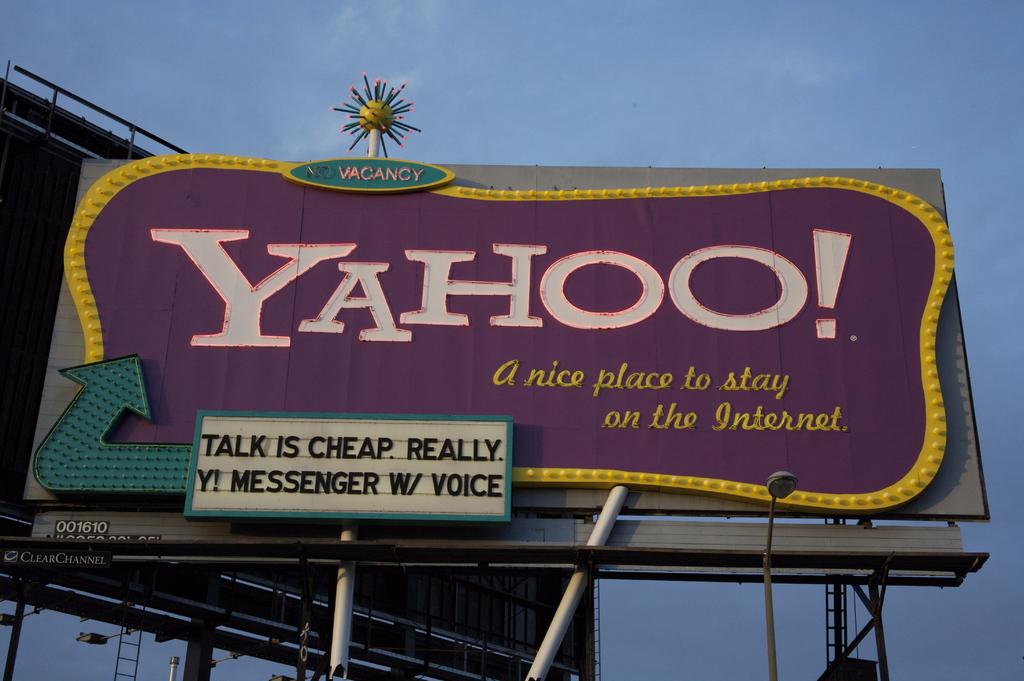What is a nice place to stay on the internet?
Your answer should be compact. Yahoo. What brand of internet?
Your response must be concise. Yahoo. 